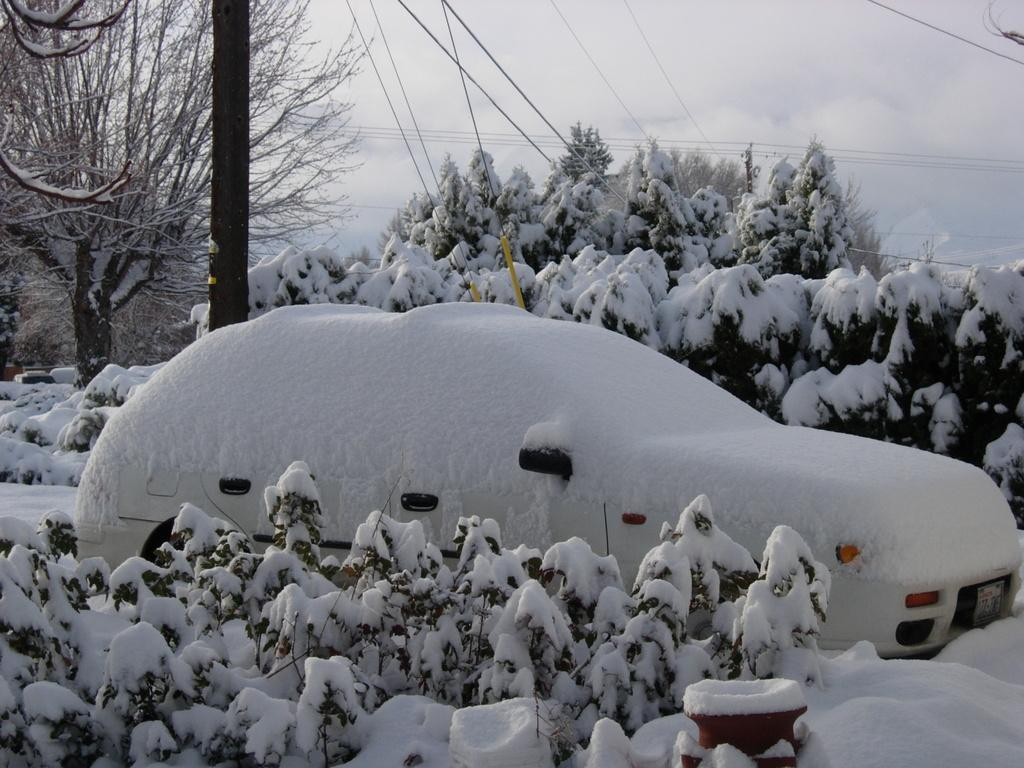What is the main subject of the image? There is a car in the image. How is the car affected by the weather? The car is covered by snow. What can be seen behind the car? There is a pole, trees, and cables behind the car. What is the condition of the sky in the image? The sky is visible and appears to be cloudy. What type of war is being depicted in the image? There is no depiction of war in the image; it features a car covered in snow with a background of a pole, trees, and cables. Can you see a playground in the image? There is no playground present in the image. 